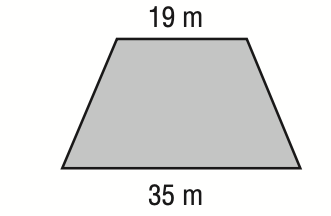Answer the mathemtical geometry problem and directly provide the correct option letter.
Question: The lengths of the bases of an isosceles trapezoid are shown below. If the perimeter is 74 meters, what is its area?
Choices: A: 162 B: 270 C: 332.5 D: 342.25 A 